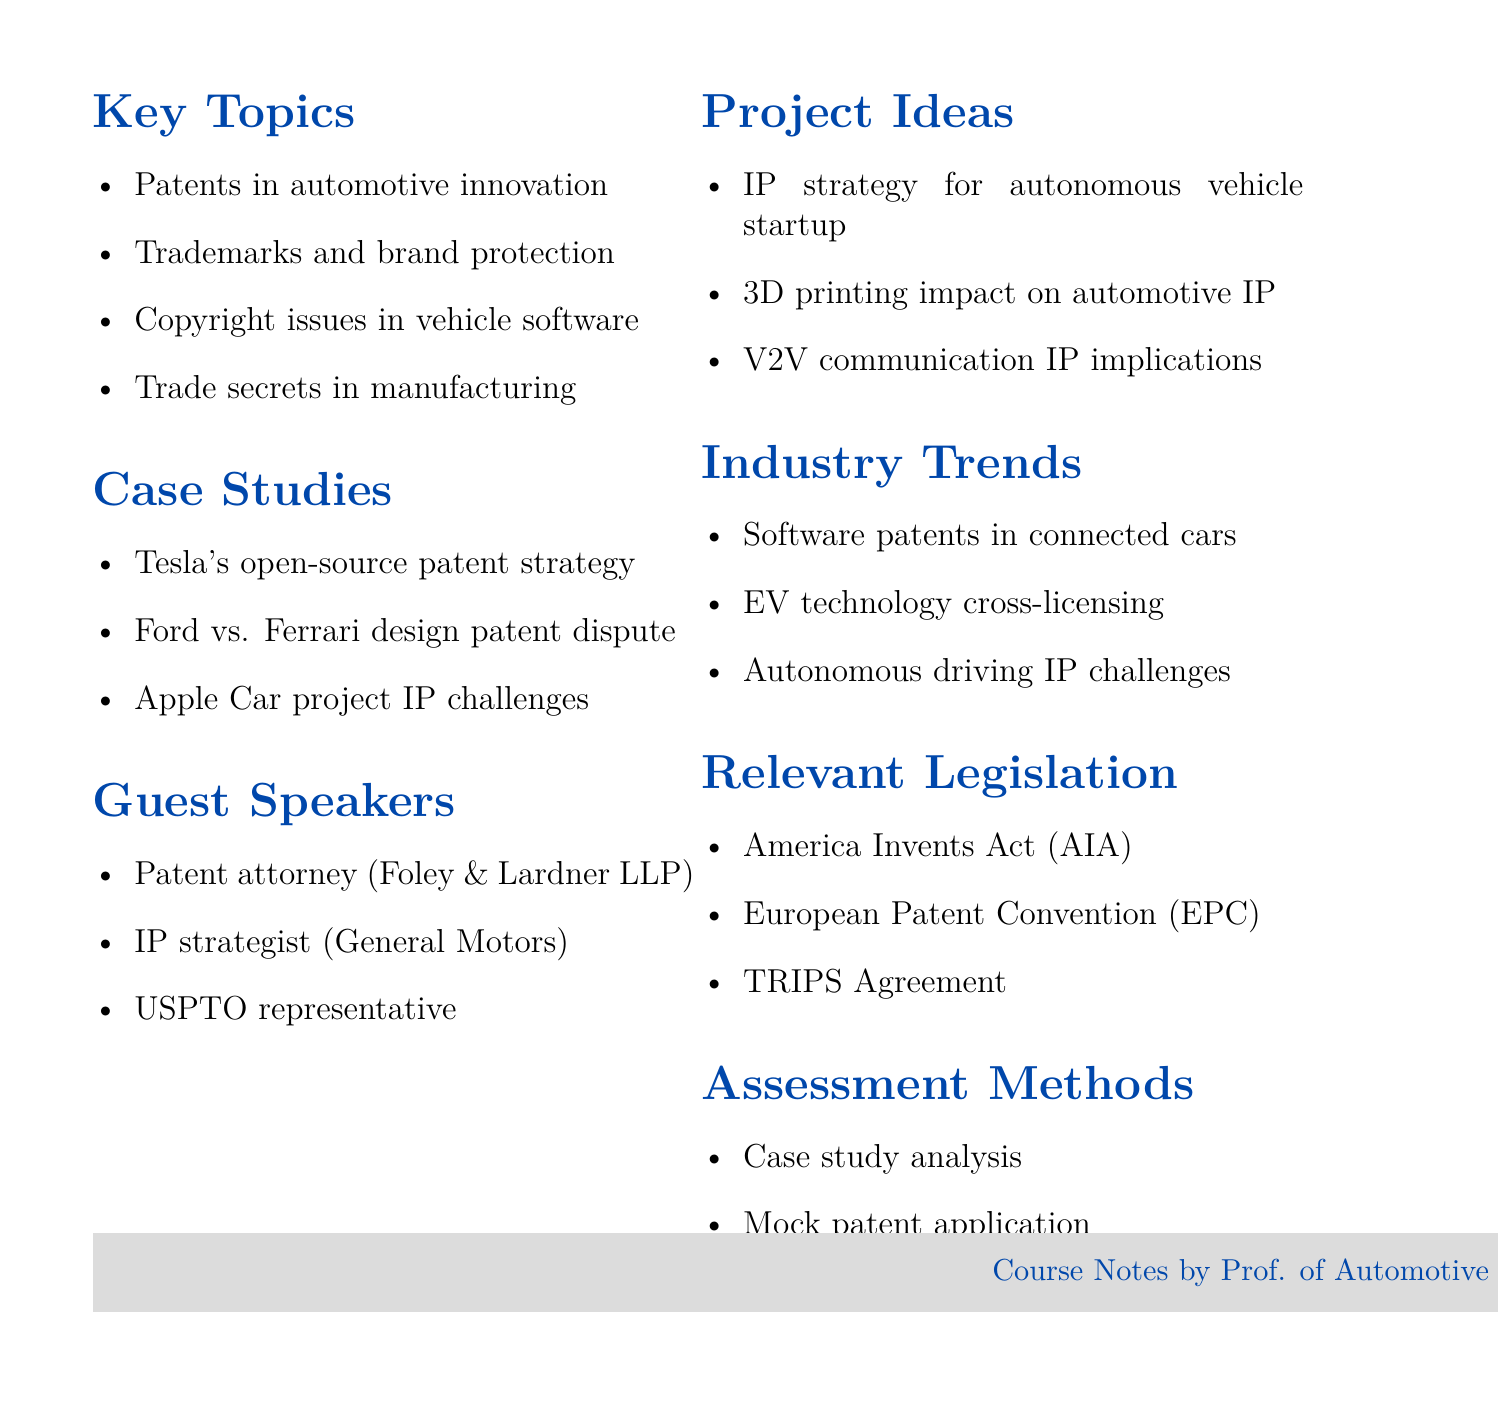What is the course title? The course title is explicitly stated in the document's header section.
Answer: Intellectual Property in Automotive Engineering How many key topics are listed? The document includes a section that counts the key topics presented.
Answer: Four Name one case study mentioned. Each case study is listed under a specific heading in the document.
Answer: Tesla's open-source patent strategy Who is one of the guest speakers? A section dedicated to guest speakers lists their names and affiliations.
Answer: Patent attorney from Foley & Lardner LLP What is one project idea proposed for the course? Project ideas are enumerated in a dedicated list within the document.
Answer: Develop an IP strategy for a hypothetical autonomous vehicle startup Which legislation is relevant to the topic? The document includes a section detailing significant legislation related to intellectual property.
Answer: America Invents Act (AIA) What assessment method involves a mock submission? The assessment methods include specific tasks for evaluating students' understanding of the content.
Answer: Mock patent application submission What industry trend is highlighted regarding vehicle technology? Trends in the industry are summarized in a focused section within the document.
Answer: Increasing importance of software patents in connected cars 